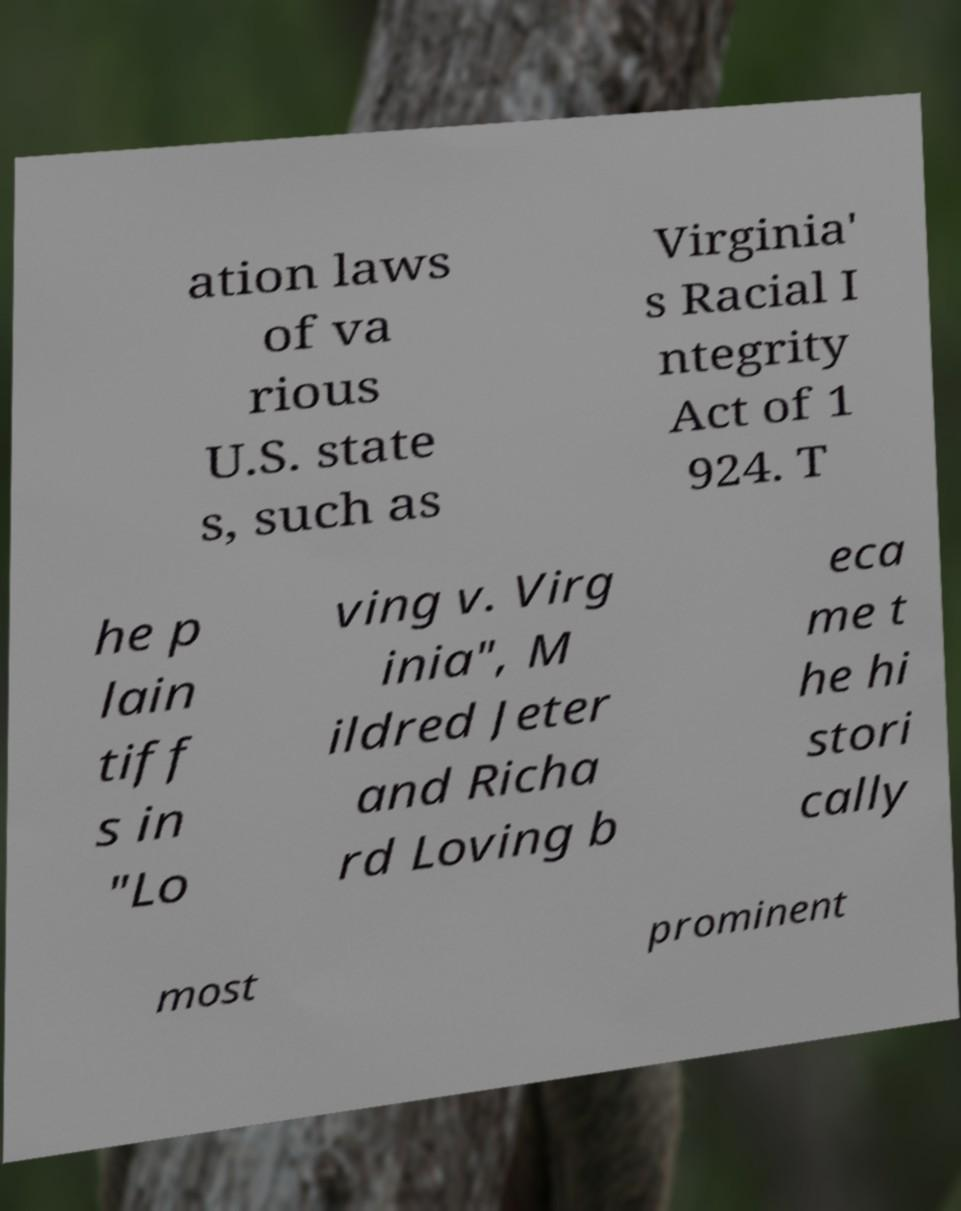Please read and relay the text visible in this image. What does it say? ation laws of va rious U.S. state s, such as Virginia' s Racial I ntegrity Act of 1 924. T he p lain tiff s in "Lo ving v. Virg inia", M ildred Jeter and Richa rd Loving b eca me t he hi stori cally most prominent 